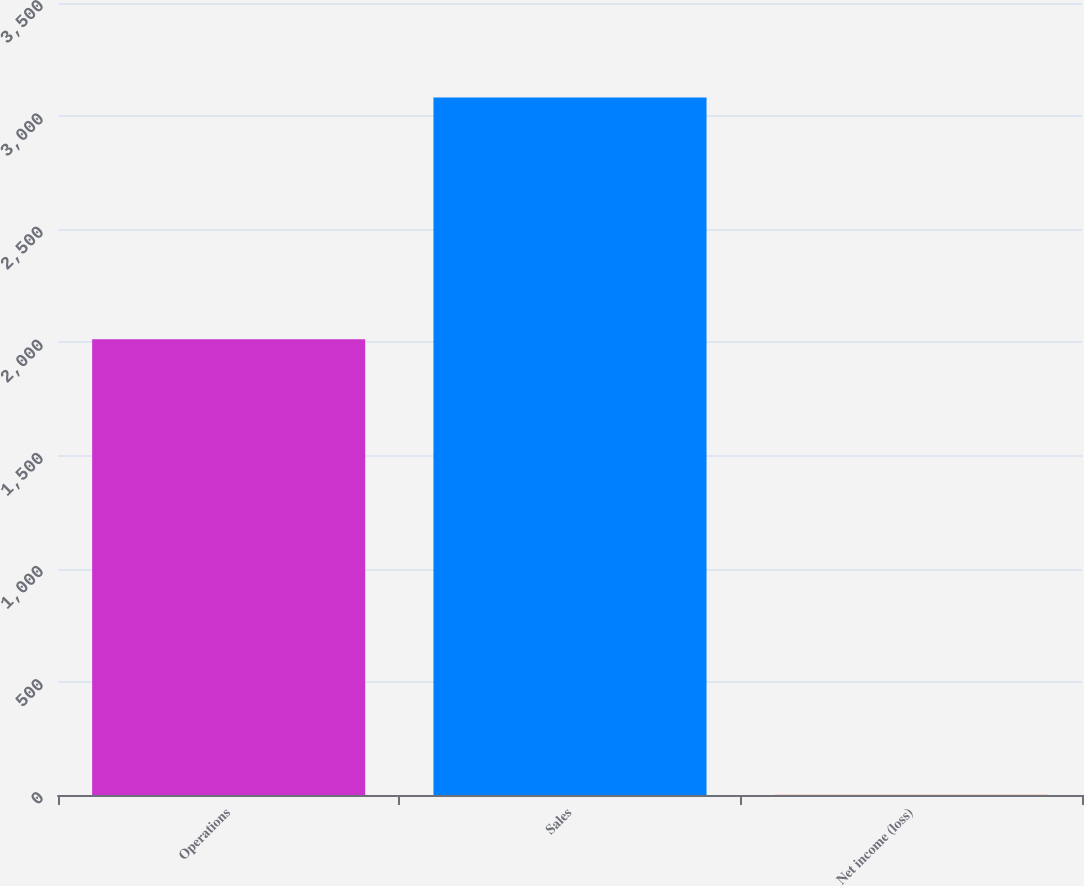Convert chart. <chart><loc_0><loc_0><loc_500><loc_500><bar_chart><fcel>Operations<fcel>Sales<fcel>Net income (loss)<nl><fcel>2014<fcel>3082<fcel>1<nl></chart> 